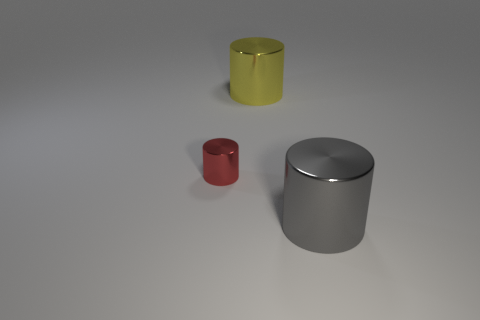The yellow object has what shape?
Provide a succinct answer. Cylinder. What size is the yellow object behind the cylinder that is in front of the red metal object?
Give a very brief answer. Large. What is the size of the metallic object in front of the red cylinder?
Your answer should be very brief. Large. Are there fewer metal things on the right side of the tiny red cylinder than tiny red cylinders that are behind the large yellow cylinder?
Give a very brief answer. No. What is the color of the small shiny cylinder?
Make the answer very short. Red. Are there any other tiny things of the same color as the tiny thing?
Offer a very short reply. No. What shape is the big shiny object that is to the right of the large cylinder on the left side of the big shiny thing that is in front of the big yellow cylinder?
Provide a short and direct response. Cylinder. There is a big object that is to the left of the big gray metal object; what is it made of?
Make the answer very short. Metal. What is the size of the red object on the left side of the cylinder behind the small red object on the left side of the yellow object?
Offer a terse response. Small. Do the gray cylinder and the metal cylinder left of the big yellow object have the same size?
Give a very brief answer. No. 